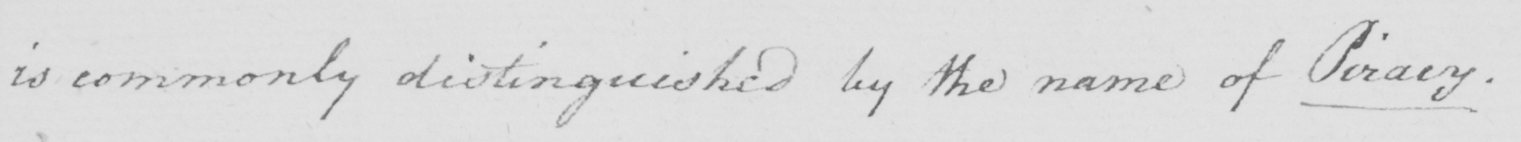Can you read and transcribe this handwriting? is commonly distinguished by the name Piracy. 